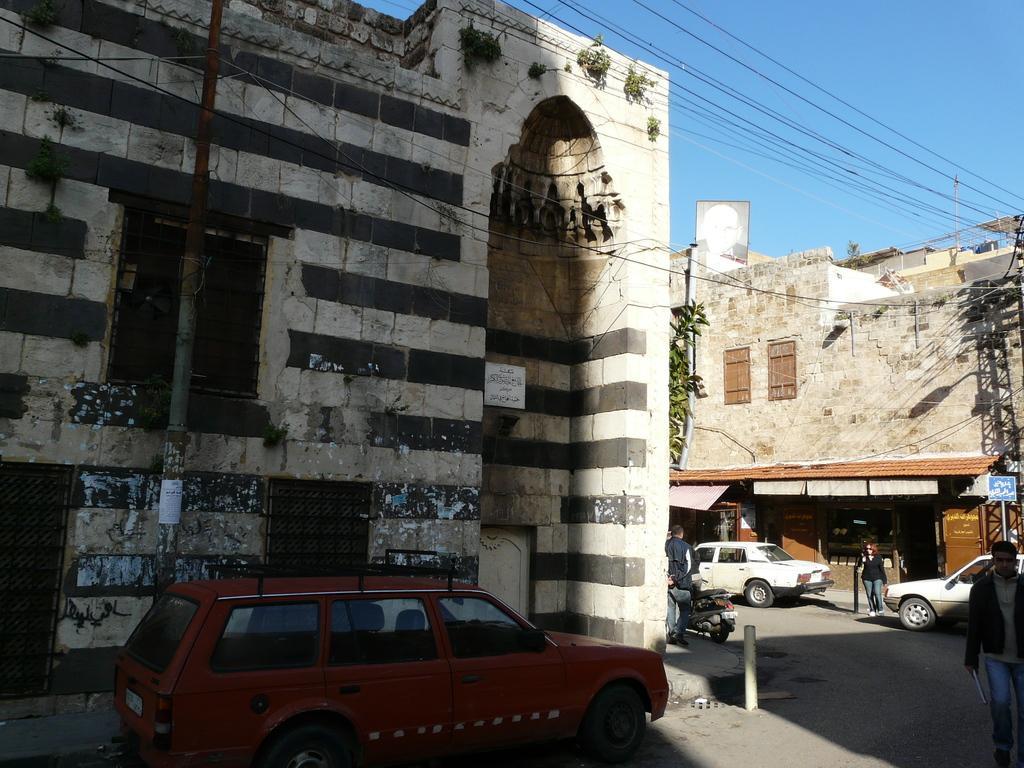In one or two sentences, can you explain what this image depicts? In this image we can see buildings, vehicles, persons, poles, tree, plants and other objects. In the background of the image there is the sky and the cables. At the bottom of the image there is the road. 